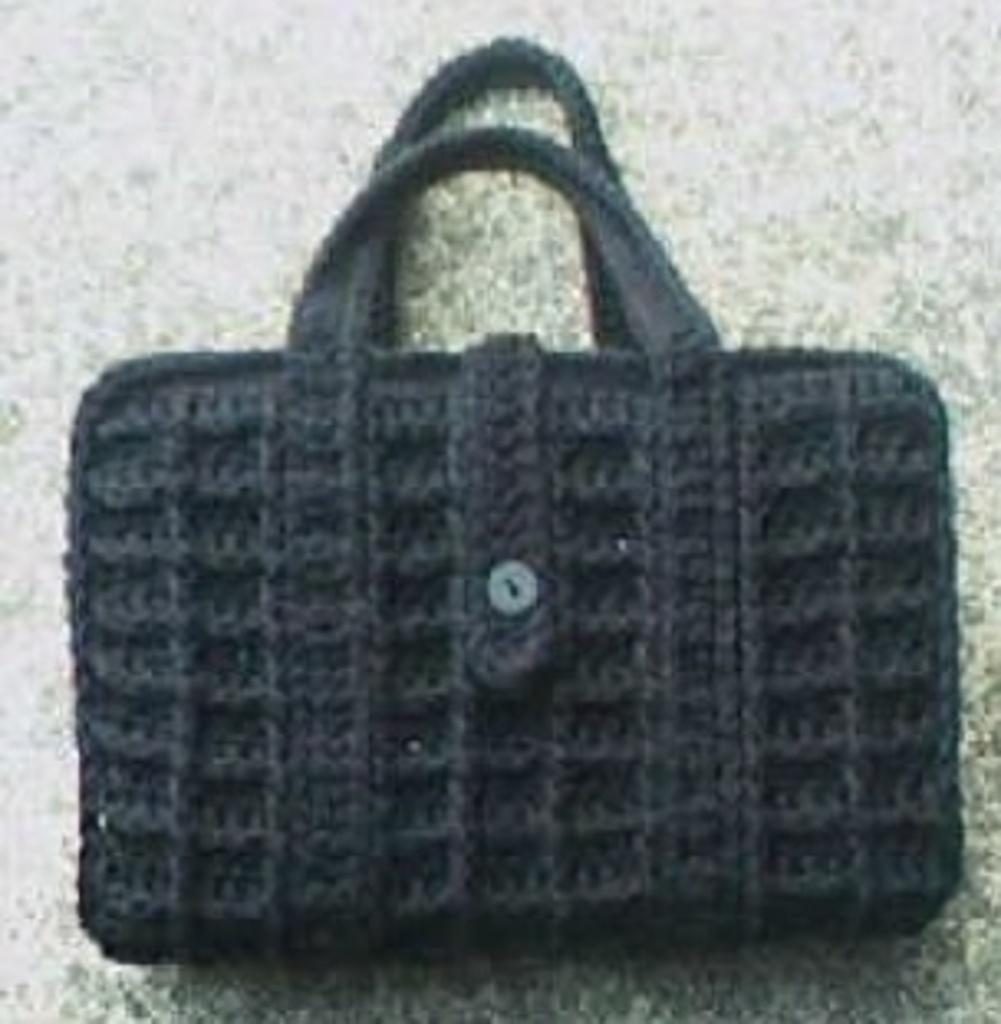What type of accessory is visible in the image? There is a handbag in the image. Can you describe a specific detail about the handbag? There is an ash-colored button on the handbag. What type of cake is being served on the tree in the image? There is no cake or tree present in the image; it only features a handbag with an ash-colored button. 